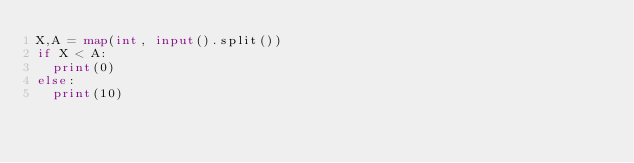<code> <loc_0><loc_0><loc_500><loc_500><_Python_>X,A = map(int, input().split())
if X < A:
  print(0)
else:
  print(10)</code> 